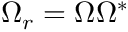<formula> <loc_0><loc_0><loc_500><loc_500>\Omega _ { r } = \Omega \Omega ^ { * }</formula> 